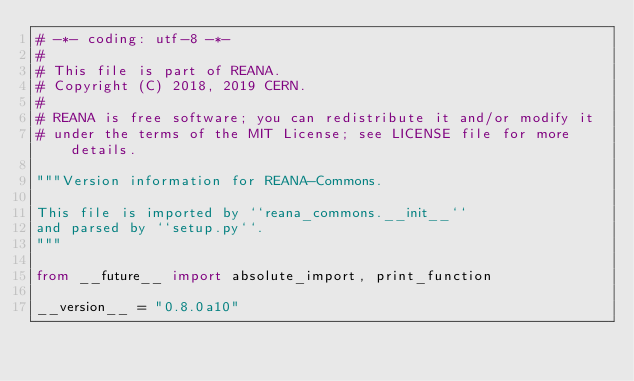Convert code to text. <code><loc_0><loc_0><loc_500><loc_500><_Python_># -*- coding: utf-8 -*-
#
# This file is part of REANA.
# Copyright (C) 2018, 2019 CERN.
#
# REANA is free software; you can redistribute it and/or modify it
# under the terms of the MIT License; see LICENSE file for more details.

"""Version information for REANA-Commons.

This file is imported by ``reana_commons.__init__``
and parsed by ``setup.py``.
"""

from __future__ import absolute_import, print_function

__version__ = "0.8.0a10"
</code> 